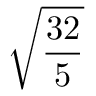Convert formula to latex. <formula><loc_0><loc_0><loc_500><loc_500>\sqrt { \frac { 3 2 } { 5 } }</formula> 